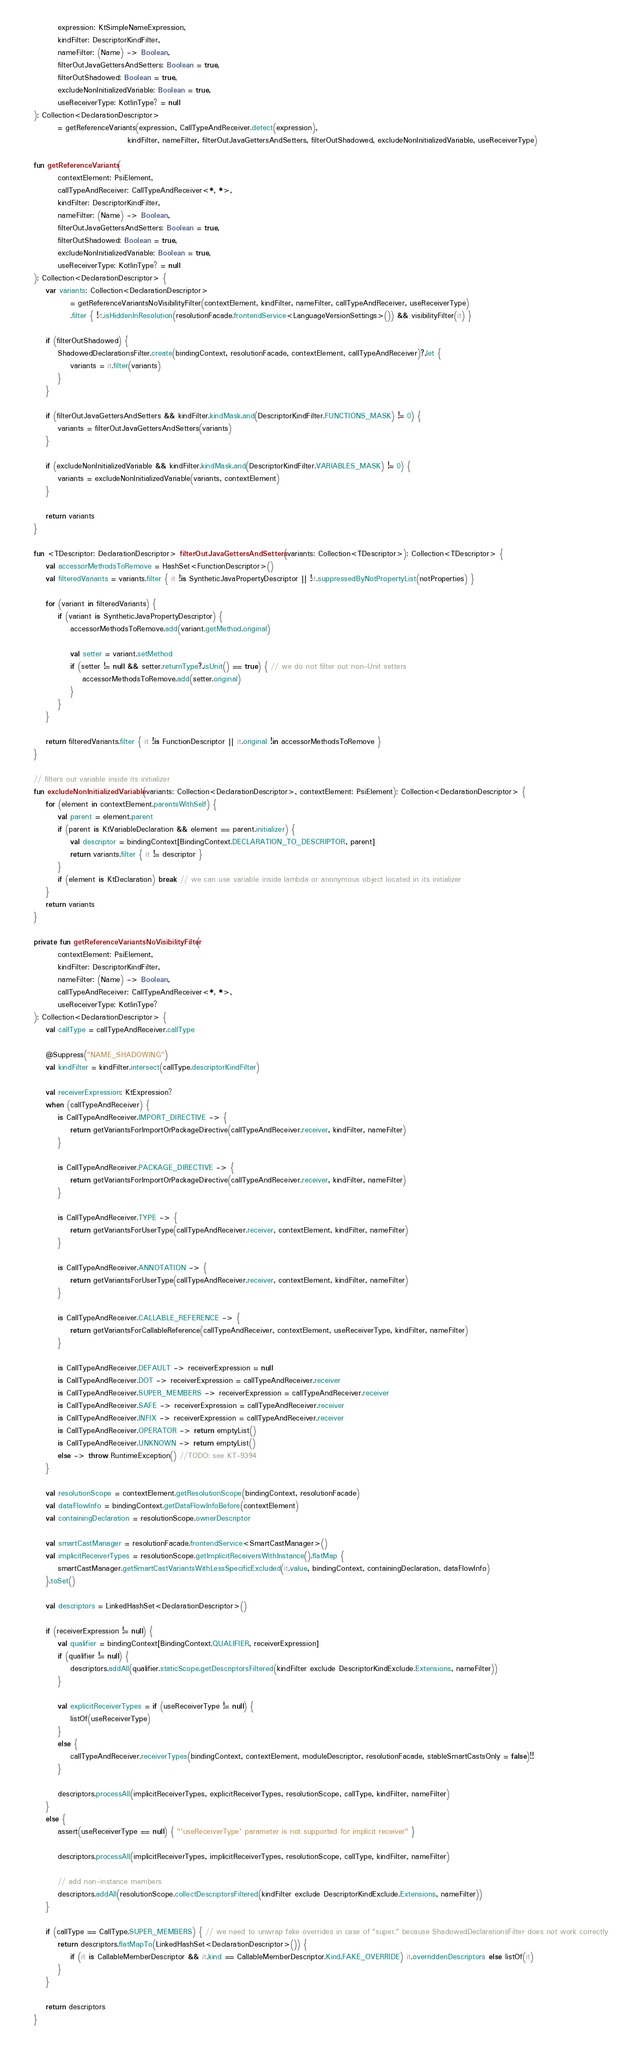Convert code to text. <code><loc_0><loc_0><loc_500><loc_500><_Kotlin_>            expression: KtSimpleNameExpression,
            kindFilter: DescriptorKindFilter,
            nameFilter: (Name) -> Boolean,
            filterOutJavaGettersAndSetters: Boolean = true,
            filterOutShadowed: Boolean = true,
            excludeNonInitializedVariable: Boolean = true,
            useReceiverType: KotlinType? = null
    ): Collection<DeclarationDescriptor>
            = getReferenceVariants(expression, CallTypeAndReceiver.detect(expression),
                                   kindFilter, nameFilter, filterOutJavaGettersAndSetters, filterOutShadowed, excludeNonInitializedVariable, useReceiverType)

    fun getReferenceVariants(
            contextElement: PsiElement,
            callTypeAndReceiver: CallTypeAndReceiver<*, *>,
            kindFilter: DescriptorKindFilter,
            nameFilter: (Name) -> Boolean,
            filterOutJavaGettersAndSetters: Boolean = true,
            filterOutShadowed: Boolean = true,
            excludeNonInitializedVariable: Boolean = true,
            useReceiverType: KotlinType? = null
    ): Collection<DeclarationDescriptor> {
        var variants: Collection<DeclarationDescriptor>
                = getReferenceVariantsNoVisibilityFilter(contextElement, kindFilter, nameFilter, callTypeAndReceiver, useReceiverType)
                .filter { !it.isHiddenInResolution(resolutionFacade.frontendService<LanguageVersionSettings>()) && visibilityFilter(it) }

        if (filterOutShadowed) {
            ShadowedDeclarationsFilter.create(bindingContext, resolutionFacade, contextElement, callTypeAndReceiver)?.let {
                variants = it.filter(variants)
            }
        }

        if (filterOutJavaGettersAndSetters && kindFilter.kindMask.and(DescriptorKindFilter.FUNCTIONS_MASK) != 0) {
            variants = filterOutJavaGettersAndSetters(variants)
        }

        if (excludeNonInitializedVariable && kindFilter.kindMask.and(DescriptorKindFilter.VARIABLES_MASK) != 0) {
            variants = excludeNonInitializedVariable(variants, contextElement)
        }

        return variants
    }

    fun <TDescriptor: DeclarationDescriptor> filterOutJavaGettersAndSetters(variants: Collection<TDescriptor>): Collection<TDescriptor> {
        val accessorMethodsToRemove = HashSet<FunctionDescriptor>()
        val filteredVariants = variants.filter { it !is SyntheticJavaPropertyDescriptor || !it.suppressedByNotPropertyList(notProperties) }

        for (variant in filteredVariants) {
            if (variant is SyntheticJavaPropertyDescriptor) {
                accessorMethodsToRemove.add(variant.getMethod.original)

                val setter = variant.setMethod
                if (setter != null && setter.returnType?.isUnit() == true) { // we do not filter out non-Unit setters
                    accessorMethodsToRemove.add(setter.original)
                }
            }
        }

        return filteredVariants.filter { it !is FunctionDescriptor || it.original !in accessorMethodsToRemove }
    }

    // filters out variable inside its initializer
    fun excludeNonInitializedVariable(variants: Collection<DeclarationDescriptor>, contextElement: PsiElement): Collection<DeclarationDescriptor> {
        for (element in contextElement.parentsWithSelf) {
            val parent = element.parent
            if (parent is KtVariableDeclaration && element == parent.initializer) {
                val descriptor = bindingContext[BindingContext.DECLARATION_TO_DESCRIPTOR, parent]
                return variants.filter { it != descriptor }
            }
            if (element is KtDeclaration) break // we can use variable inside lambda or anonymous object located in its initializer
        }
        return variants
    }

    private fun getReferenceVariantsNoVisibilityFilter(
            contextElement: PsiElement,
            kindFilter: DescriptorKindFilter,
            nameFilter: (Name) -> Boolean,
            callTypeAndReceiver: CallTypeAndReceiver<*, *>,
            useReceiverType: KotlinType?
    ): Collection<DeclarationDescriptor> {
        val callType = callTypeAndReceiver.callType

        @Suppress("NAME_SHADOWING")
        val kindFilter = kindFilter.intersect(callType.descriptorKindFilter)

        val receiverExpression: KtExpression?
        when (callTypeAndReceiver) {
            is CallTypeAndReceiver.IMPORT_DIRECTIVE -> {
                return getVariantsForImportOrPackageDirective(callTypeAndReceiver.receiver, kindFilter, nameFilter)
            }

            is CallTypeAndReceiver.PACKAGE_DIRECTIVE -> {
                return getVariantsForImportOrPackageDirective(callTypeAndReceiver.receiver, kindFilter, nameFilter)
            }

            is CallTypeAndReceiver.TYPE -> {
                return getVariantsForUserType(callTypeAndReceiver.receiver, contextElement, kindFilter, nameFilter)
            }

            is CallTypeAndReceiver.ANNOTATION -> {
                return getVariantsForUserType(callTypeAndReceiver.receiver, contextElement, kindFilter, nameFilter)
            }

            is CallTypeAndReceiver.CALLABLE_REFERENCE -> {
                return getVariantsForCallableReference(callTypeAndReceiver, contextElement, useReceiverType, kindFilter, nameFilter)
            }

            is CallTypeAndReceiver.DEFAULT -> receiverExpression = null
            is CallTypeAndReceiver.DOT -> receiverExpression = callTypeAndReceiver.receiver
            is CallTypeAndReceiver.SUPER_MEMBERS -> receiverExpression = callTypeAndReceiver.receiver
            is CallTypeAndReceiver.SAFE -> receiverExpression = callTypeAndReceiver.receiver
            is CallTypeAndReceiver.INFIX -> receiverExpression = callTypeAndReceiver.receiver
            is CallTypeAndReceiver.OPERATOR -> return emptyList()
            is CallTypeAndReceiver.UNKNOWN -> return emptyList()
            else -> throw RuntimeException() //TODO: see KT-9394
        }

        val resolutionScope = contextElement.getResolutionScope(bindingContext, resolutionFacade)
        val dataFlowInfo = bindingContext.getDataFlowInfoBefore(contextElement)
        val containingDeclaration = resolutionScope.ownerDescriptor

        val smartCastManager = resolutionFacade.frontendService<SmartCastManager>()
        val implicitReceiverTypes = resolutionScope.getImplicitReceiversWithInstance().flatMap {
            smartCastManager.getSmartCastVariantsWithLessSpecificExcluded(it.value, bindingContext, containingDeclaration, dataFlowInfo)
        }.toSet()

        val descriptors = LinkedHashSet<DeclarationDescriptor>()

        if (receiverExpression != null) {
            val qualifier = bindingContext[BindingContext.QUALIFIER, receiverExpression]
            if (qualifier != null) {
                descriptors.addAll(qualifier.staticScope.getDescriptorsFiltered(kindFilter exclude DescriptorKindExclude.Extensions, nameFilter))
            }

            val explicitReceiverTypes = if (useReceiverType != null) {
                listOf(useReceiverType)
            }
            else {
                callTypeAndReceiver.receiverTypes(bindingContext, contextElement, moduleDescriptor, resolutionFacade, stableSmartCastsOnly = false)!!
            }

            descriptors.processAll(implicitReceiverTypes, explicitReceiverTypes, resolutionScope, callType, kindFilter, nameFilter)
        }
        else {
            assert(useReceiverType == null) { "'useReceiverType' parameter is not supported for implicit receiver" }

            descriptors.processAll(implicitReceiverTypes, implicitReceiverTypes, resolutionScope, callType, kindFilter, nameFilter)

            // add non-instance members
            descriptors.addAll(resolutionScope.collectDescriptorsFiltered(kindFilter exclude DescriptorKindExclude.Extensions, nameFilter))
        }

        if (callType == CallType.SUPER_MEMBERS) { // we need to unwrap fake overrides in case of "super." because ShadowedDeclarationsFilter does not work correctly
            return descriptors.flatMapTo(LinkedHashSet<DeclarationDescriptor>()) {
                if (it is CallableMemberDescriptor && it.kind == CallableMemberDescriptor.Kind.FAKE_OVERRIDE) it.overriddenDescriptors else listOf(it)
            }
        }

        return descriptors
    }
</code> 